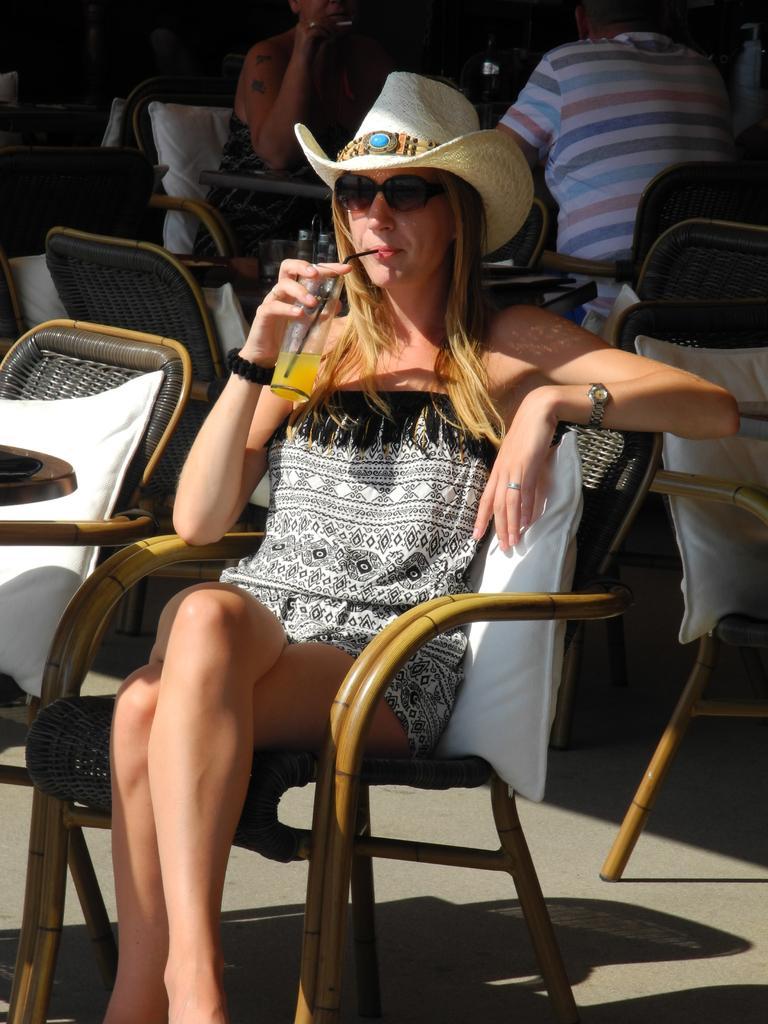In one or two sentences, can you explain what this image depicts? In this picture we can see women wore cap, goggles, watch sitting on chair and holding glass in her hand and drinking with straw and in the background we can see a man and woman and some chairs. 